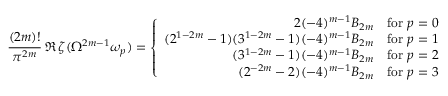<formula> <loc_0><loc_0><loc_500><loc_500>\frac { ( 2 m ) ! } { \pi ^ { 2 m } } \, \Re \, \zeta ( \Omega ^ { 2 m - 1 } \omega _ { p } ) = \left \{ \begin{array} { r r r } { { 2 ( - 4 ) ^ { m - 1 } B _ { 2 m } } } & { f o r p = 0 } \\ { { ( 2 ^ { 1 - 2 m } - 1 ) ( 3 ^ { 1 - 2 m } - 1 ) ( - 4 ) ^ { m - 1 } B _ { 2 m } } } & { f o r p = 1 } \\ { { ( 3 ^ { 1 - 2 m } - 1 ) ( - 4 ) ^ { m - 1 } B _ { 2 m } } } & { f o r p = 2 } \\ { { ( 2 ^ { - 2 m } - 2 ) ( - 4 ) ^ { m - 1 } B _ { 2 m } } } & { f o r p = 3 } \end{array}</formula> 